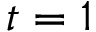<formula> <loc_0><loc_0><loc_500><loc_500>t = 1</formula> 